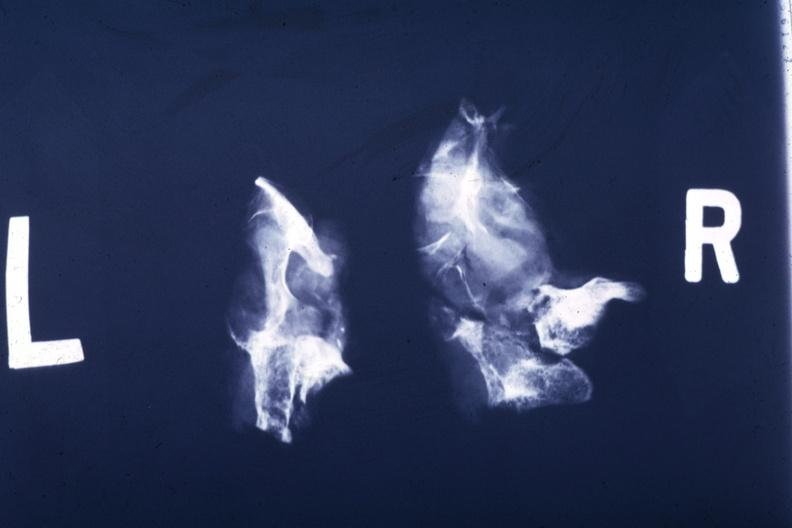s malignant adenoma present?
Answer the question using a single word or phrase. Yes 